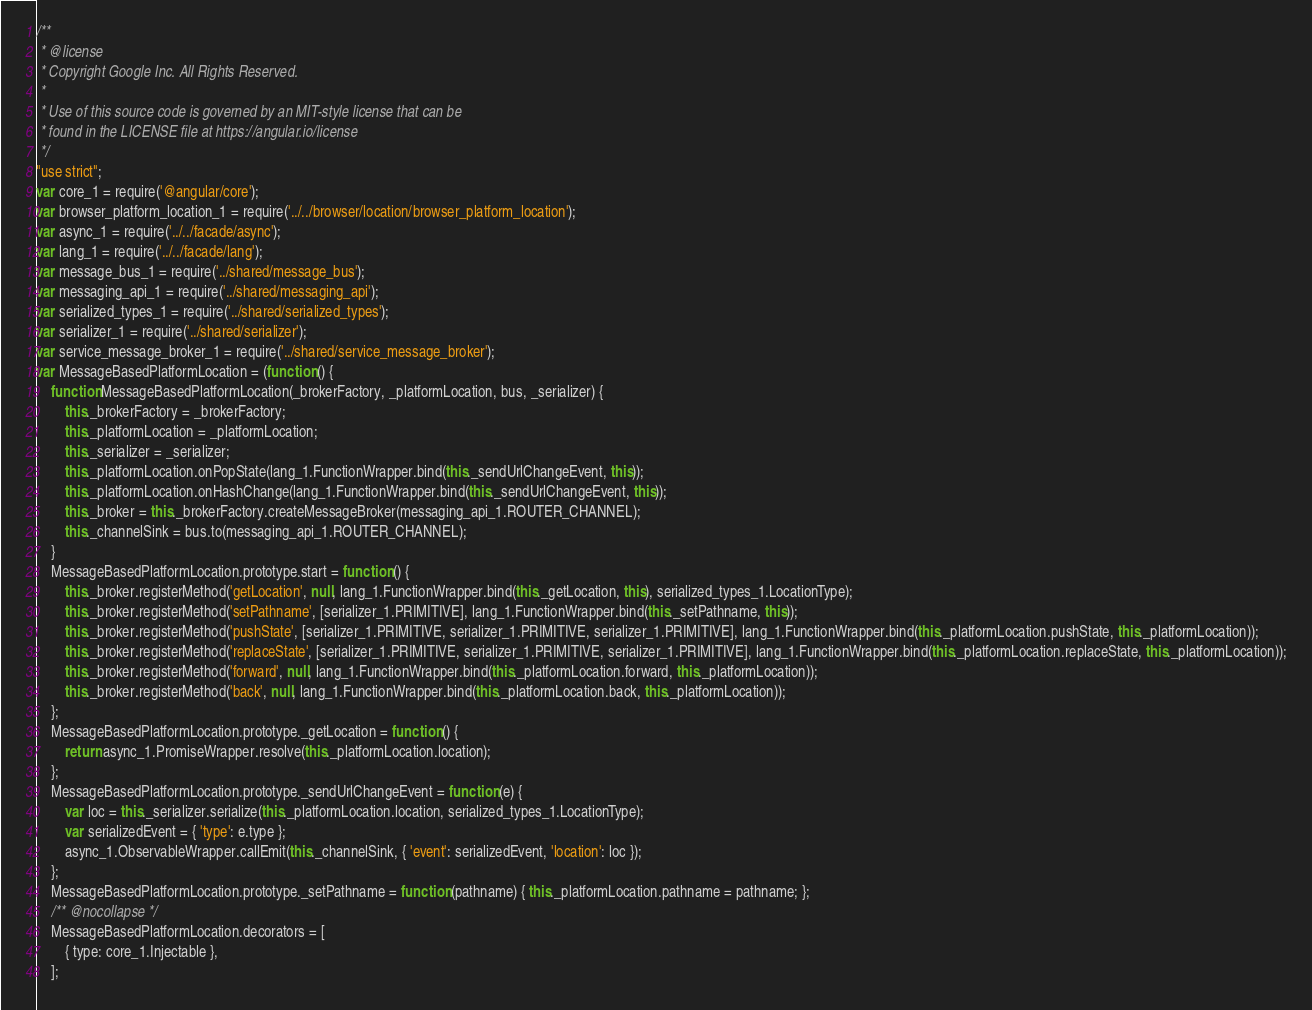Convert code to text. <code><loc_0><loc_0><loc_500><loc_500><_JavaScript_>/**
 * @license
 * Copyright Google Inc. All Rights Reserved.
 *
 * Use of this source code is governed by an MIT-style license that can be
 * found in the LICENSE file at https://angular.io/license
 */
"use strict";
var core_1 = require('@angular/core');
var browser_platform_location_1 = require('../../browser/location/browser_platform_location');
var async_1 = require('../../facade/async');
var lang_1 = require('../../facade/lang');
var message_bus_1 = require('../shared/message_bus');
var messaging_api_1 = require('../shared/messaging_api');
var serialized_types_1 = require('../shared/serialized_types');
var serializer_1 = require('../shared/serializer');
var service_message_broker_1 = require('../shared/service_message_broker');
var MessageBasedPlatformLocation = (function () {
    function MessageBasedPlatformLocation(_brokerFactory, _platformLocation, bus, _serializer) {
        this._brokerFactory = _brokerFactory;
        this._platformLocation = _platformLocation;
        this._serializer = _serializer;
        this._platformLocation.onPopState(lang_1.FunctionWrapper.bind(this._sendUrlChangeEvent, this));
        this._platformLocation.onHashChange(lang_1.FunctionWrapper.bind(this._sendUrlChangeEvent, this));
        this._broker = this._brokerFactory.createMessageBroker(messaging_api_1.ROUTER_CHANNEL);
        this._channelSink = bus.to(messaging_api_1.ROUTER_CHANNEL);
    }
    MessageBasedPlatformLocation.prototype.start = function () {
        this._broker.registerMethod('getLocation', null, lang_1.FunctionWrapper.bind(this._getLocation, this), serialized_types_1.LocationType);
        this._broker.registerMethod('setPathname', [serializer_1.PRIMITIVE], lang_1.FunctionWrapper.bind(this._setPathname, this));
        this._broker.registerMethod('pushState', [serializer_1.PRIMITIVE, serializer_1.PRIMITIVE, serializer_1.PRIMITIVE], lang_1.FunctionWrapper.bind(this._platformLocation.pushState, this._platformLocation));
        this._broker.registerMethod('replaceState', [serializer_1.PRIMITIVE, serializer_1.PRIMITIVE, serializer_1.PRIMITIVE], lang_1.FunctionWrapper.bind(this._platformLocation.replaceState, this._platformLocation));
        this._broker.registerMethod('forward', null, lang_1.FunctionWrapper.bind(this._platformLocation.forward, this._platformLocation));
        this._broker.registerMethod('back', null, lang_1.FunctionWrapper.bind(this._platformLocation.back, this._platformLocation));
    };
    MessageBasedPlatformLocation.prototype._getLocation = function () {
        return async_1.PromiseWrapper.resolve(this._platformLocation.location);
    };
    MessageBasedPlatformLocation.prototype._sendUrlChangeEvent = function (e) {
        var loc = this._serializer.serialize(this._platformLocation.location, serialized_types_1.LocationType);
        var serializedEvent = { 'type': e.type };
        async_1.ObservableWrapper.callEmit(this._channelSink, { 'event': serializedEvent, 'location': loc });
    };
    MessageBasedPlatformLocation.prototype._setPathname = function (pathname) { this._platformLocation.pathname = pathname; };
    /** @nocollapse */
    MessageBasedPlatformLocation.decorators = [
        { type: core_1.Injectable },
    ];</code> 